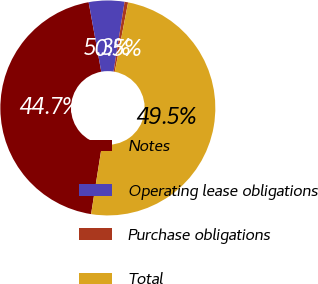<chart> <loc_0><loc_0><loc_500><loc_500><pie_chart><fcel>Notes<fcel>Operating lease obligations<fcel>Purchase obligations<fcel>Total<nl><fcel>44.65%<fcel>5.35%<fcel>0.53%<fcel>49.47%<nl></chart> 